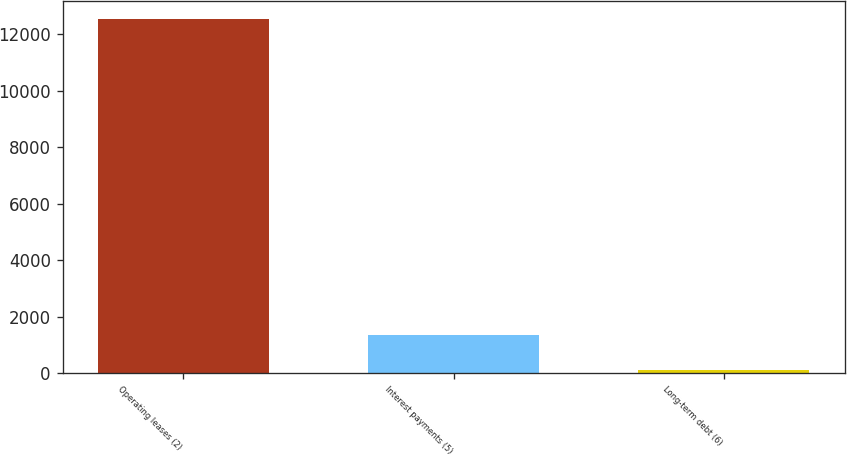<chart> <loc_0><loc_0><loc_500><loc_500><bar_chart><fcel>Operating leases (2)<fcel>Interest payments (5)<fcel>Long-term debt (6)<nl><fcel>12535<fcel>1350.7<fcel>108<nl></chart> 